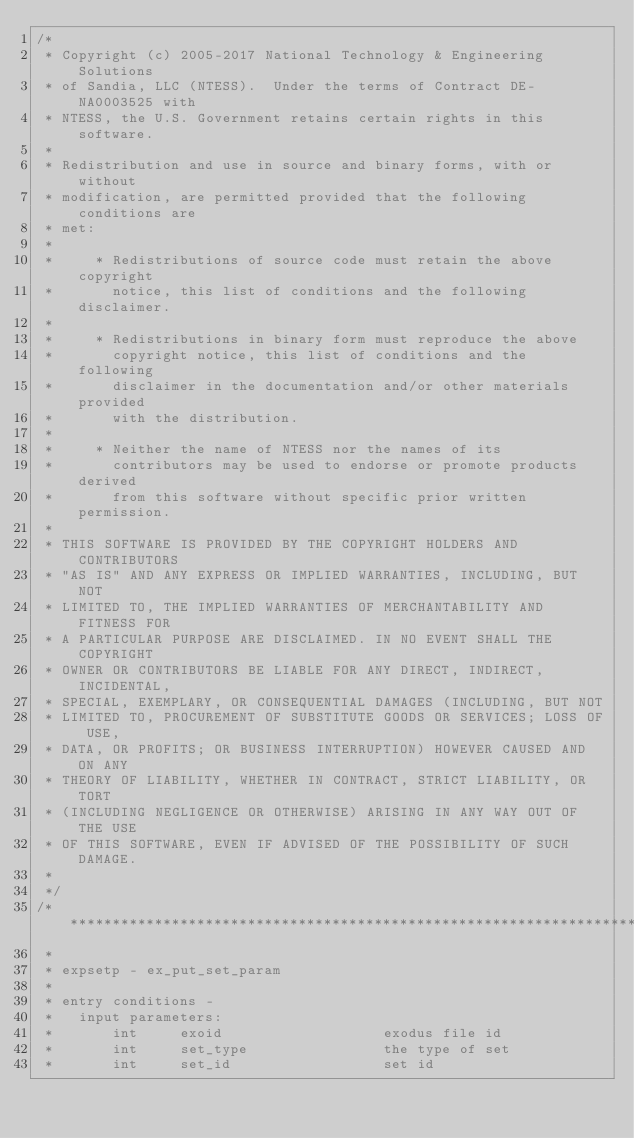<code> <loc_0><loc_0><loc_500><loc_500><_C_>/*
 * Copyright (c) 2005-2017 National Technology & Engineering Solutions
 * of Sandia, LLC (NTESS).  Under the terms of Contract DE-NA0003525 with
 * NTESS, the U.S. Government retains certain rights in this software.
 *
 * Redistribution and use in source and binary forms, with or without
 * modification, are permitted provided that the following conditions are
 * met:
 *
 *     * Redistributions of source code must retain the above copyright
 *       notice, this list of conditions and the following disclaimer.
 *
 *     * Redistributions in binary form must reproduce the above
 *       copyright notice, this list of conditions and the following
 *       disclaimer in the documentation and/or other materials provided
 *       with the distribution.
 *
 *     * Neither the name of NTESS nor the names of its
 *       contributors may be used to endorse or promote products derived
 *       from this software without specific prior written permission.
 *
 * THIS SOFTWARE IS PROVIDED BY THE COPYRIGHT HOLDERS AND CONTRIBUTORS
 * "AS IS" AND ANY EXPRESS OR IMPLIED WARRANTIES, INCLUDING, BUT NOT
 * LIMITED TO, THE IMPLIED WARRANTIES OF MERCHANTABILITY AND FITNESS FOR
 * A PARTICULAR PURPOSE ARE DISCLAIMED. IN NO EVENT SHALL THE COPYRIGHT
 * OWNER OR CONTRIBUTORS BE LIABLE FOR ANY DIRECT, INDIRECT, INCIDENTAL,
 * SPECIAL, EXEMPLARY, OR CONSEQUENTIAL DAMAGES (INCLUDING, BUT NOT
 * LIMITED TO, PROCUREMENT OF SUBSTITUTE GOODS OR SERVICES; LOSS OF USE,
 * DATA, OR PROFITS; OR BUSINESS INTERRUPTION) HOWEVER CAUSED AND ON ANY
 * THEORY OF LIABILITY, WHETHER IN CONTRACT, STRICT LIABILITY, OR TORT
 * (INCLUDING NEGLIGENCE OR OTHERWISE) ARISING IN ANY WAY OUT OF THE USE
 * OF THIS SOFTWARE, EVEN IF ADVISED OF THE POSSIBILITY OF SUCH DAMAGE.
 *
 */
/*****************************************************************************
 *
 * expsetp - ex_put_set_param
 *
 * entry conditions -
 *   input parameters:
 *       int     exoid                   exodus file id
 *       int     set_type                the type of set
 *       int     set_id                  set id</code> 